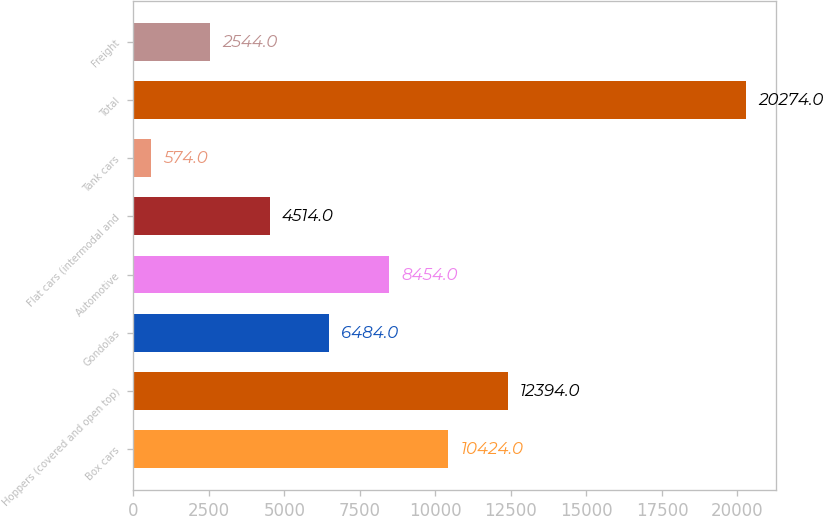<chart> <loc_0><loc_0><loc_500><loc_500><bar_chart><fcel>Box cars<fcel>Hoppers (covered and open top)<fcel>Gondolas<fcel>Automotive<fcel>Flat cars (intermodal and<fcel>Tank cars<fcel>Total<fcel>Freight<nl><fcel>10424<fcel>12394<fcel>6484<fcel>8454<fcel>4514<fcel>574<fcel>20274<fcel>2544<nl></chart> 